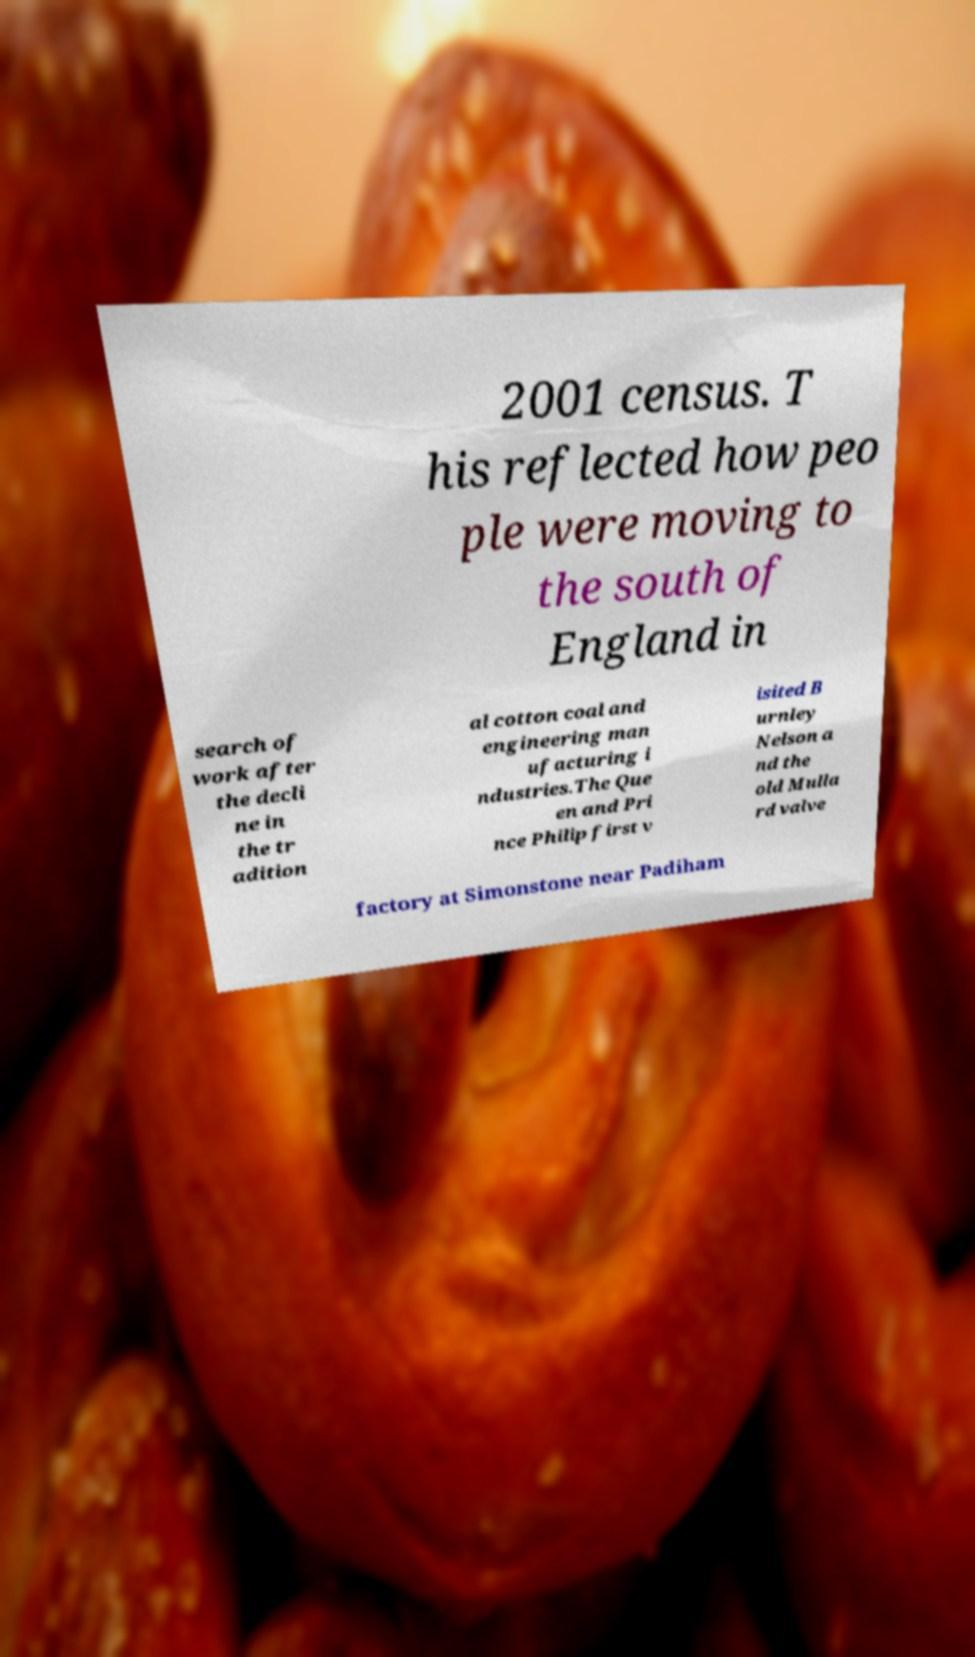Can you accurately transcribe the text from the provided image for me? 2001 census. T his reflected how peo ple were moving to the south of England in search of work after the decli ne in the tr adition al cotton coal and engineering man ufacturing i ndustries.The Que en and Pri nce Philip first v isited B urnley Nelson a nd the old Mulla rd valve factory at Simonstone near Padiham 